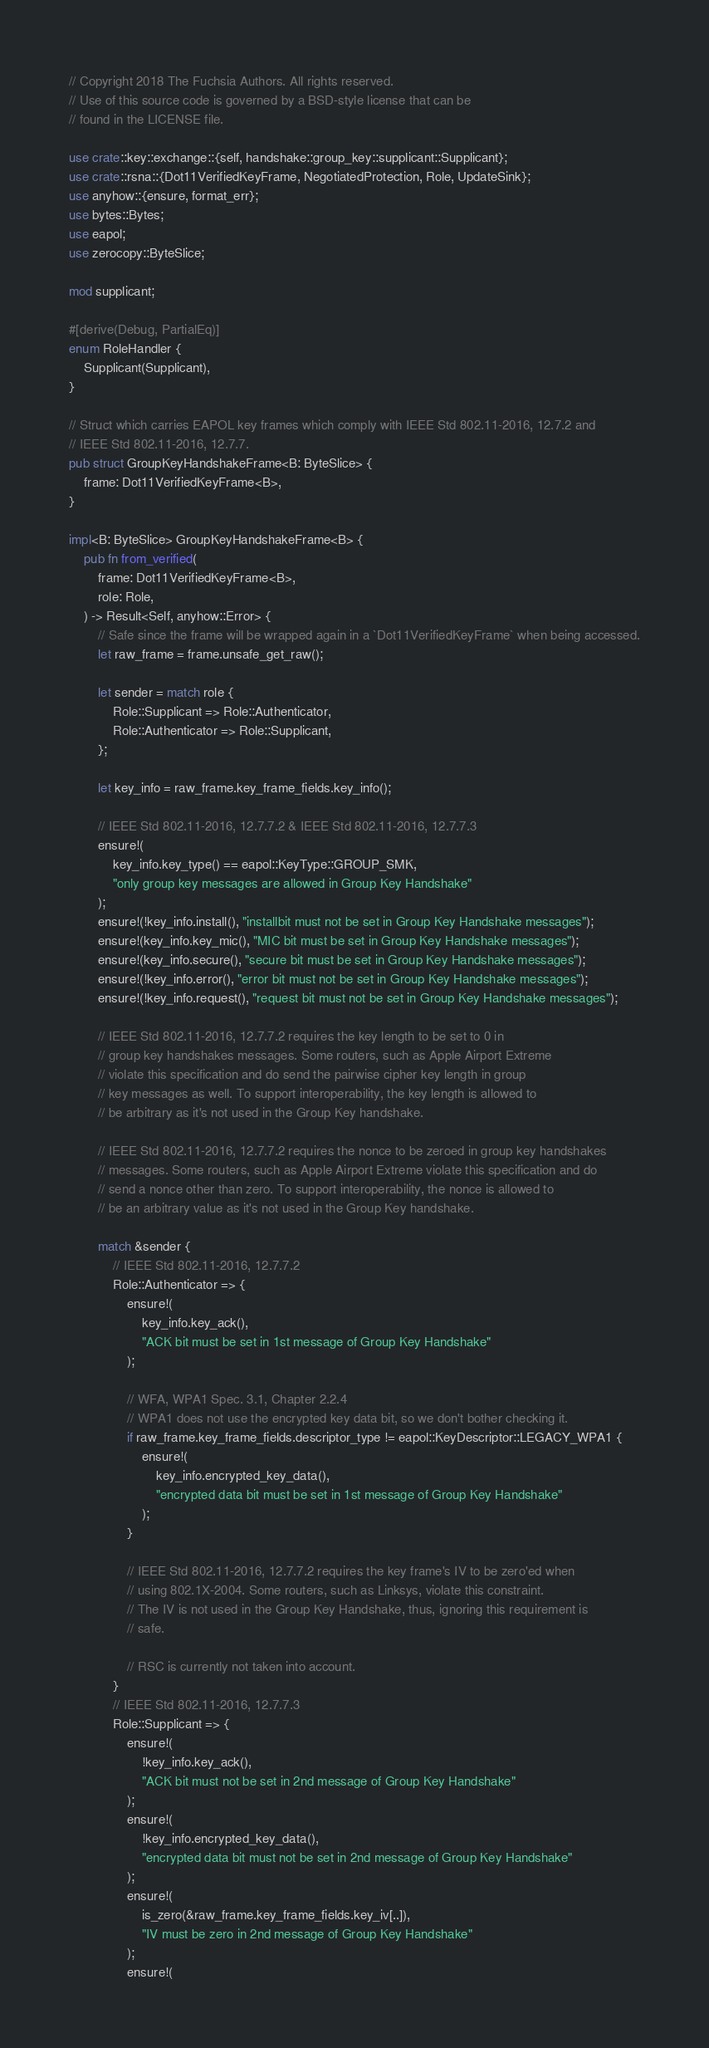<code> <loc_0><loc_0><loc_500><loc_500><_Rust_>// Copyright 2018 The Fuchsia Authors. All rights reserved.
// Use of this source code is governed by a BSD-style license that can be
// found in the LICENSE file.

use crate::key::exchange::{self, handshake::group_key::supplicant::Supplicant};
use crate::rsna::{Dot11VerifiedKeyFrame, NegotiatedProtection, Role, UpdateSink};
use anyhow::{ensure, format_err};
use bytes::Bytes;
use eapol;
use zerocopy::ByteSlice;

mod supplicant;

#[derive(Debug, PartialEq)]
enum RoleHandler {
    Supplicant(Supplicant),
}

// Struct which carries EAPOL key frames which comply with IEEE Std 802.11-2016, 12.7.2 and
// IEEE Std 802.11-2016, 12.7.7.
pub struct GroupKeyHandshakeFrame<B: ByteSlice> {
    frame: Dot11VerifiedKeyFrame<B>,
}

impl<B: ByteSlice> GroupKeyHandshakeFrame<B> {
    pub fn from_verified(
        frame: Dot11VerifiedKeyFrame<B>,
        role: Role,
    ) -> Result<Self, anyhow::Error> {
        // Safe since the frame will be wrapped again in a `Dot11VerifiedKeyFrame` when being accessed.
        let raw_frame = frame.unsafe_get_raw();

        let sender = match role {
            Role::Supplicant => Role::Authenticator,
            Role::Authenticator => Role::Supplicant,
        };

        let key_info = raw_frame.key_frame_fields.key_info();

        // IEEE Std 802.11-2016, 12.7.7.2 & IEEE Std 802.11-2016, 12.7.7.3
        ensure!(
            key_info.key_type() == eapol::KeyType::GROUP_SMK,
            "only group key messages are allowed in Group Key Handshake"
        );
        ensure!(!key_info.install(), "installbit must not be set in Group Key Handshake messages");
        ensure!(key_info.key_mic(), "MIC bit must be set in Group Key Handshake messages");
        ensure!(key_info.secure(), "secure bit must be set in Group Key Handshake messages");
        ensure!(!key_info.error(), "error bit must not be set in Group Key Handshake messages");
        ensure!(!key_info.request(), "request bit must not be set in Group Key Handshake messages");

        // IEEE Std 802.11-2016, 12.7.7.2 requires the key length to be set to 0 in
        // group key handshakes messages. Some routers, such as Apple Airport Extreme
        // violate this specification and do send the pairwise cipher key length in group
        // key messages as well. To support interoperability, the key length is allowed to
        // be arbitrary as it's not used in the Group Key handshake.

        // IEEE Std 802.11-2016, 12.7.7.2 requires the nonce to be zeroed in group key handshakes
        // messages. Some routers, such as Apple Airport Extreme violate this specification and do
        // send a nonce other than zero. To support interoperability, the nonce is allowed to
        // be an arbitrary value as it's not used in the Group Key handshake.

        match &sender {
            // IEEE Std 802.11-2016, 12.7.7.2
            Role::Authenticator => {
                ensure!(
                    key_info.key_ack(),
                    "ACK bit must be set in 1st message of Group Key Handshake"
                );

                // WFA, WPA1 Spec. 3.1, Chapter 2.2.4
                // WPA1 does not use the encrypted key data bit, so we don't bother checking it.
                if raw_frame.key_frame_fields.descriptor_type != eapol::KeyDescriptor::LEGACY_WPA1 {
                    ensure!(
                        key_info.encrypted_key_data(),
                        "encrypted data bit must be set in 1st message of Group Key Handshake"
                    );
                }

                // IEEE Std 802.11-2016, 12.7.7.2 requires the key frame's IV to be zero'ed when
                // using 802.1X-2004. Some routers, such as Linksys, violate this constraint.
                // The IV is not used in the Group Key Handshake, thus, ignoring this requirement is
                // safe.

                // RSC is currently not taken into account.
            }
            // IEEE Std 802.11-2016, 12.7.7.3
            Role::Supplicant => {
                ensure!(
                    !key_info.key_ack(),
                    "ACK bit must not be set in 2nd message of Group Key Handshake"
                );
                ensure!(
                    !key_info.encrypted_key_data(),
                    "encrypted data bit must not be set in 2nd message of Group Key Handshake"
                );
                ensure!(
                    is_zero(&raw_frame.key_frame_fields.key_iv[..]),
                    "IV must be zero in 2nd message of Group Key Handshake"
                );
                ensure!(</code> 